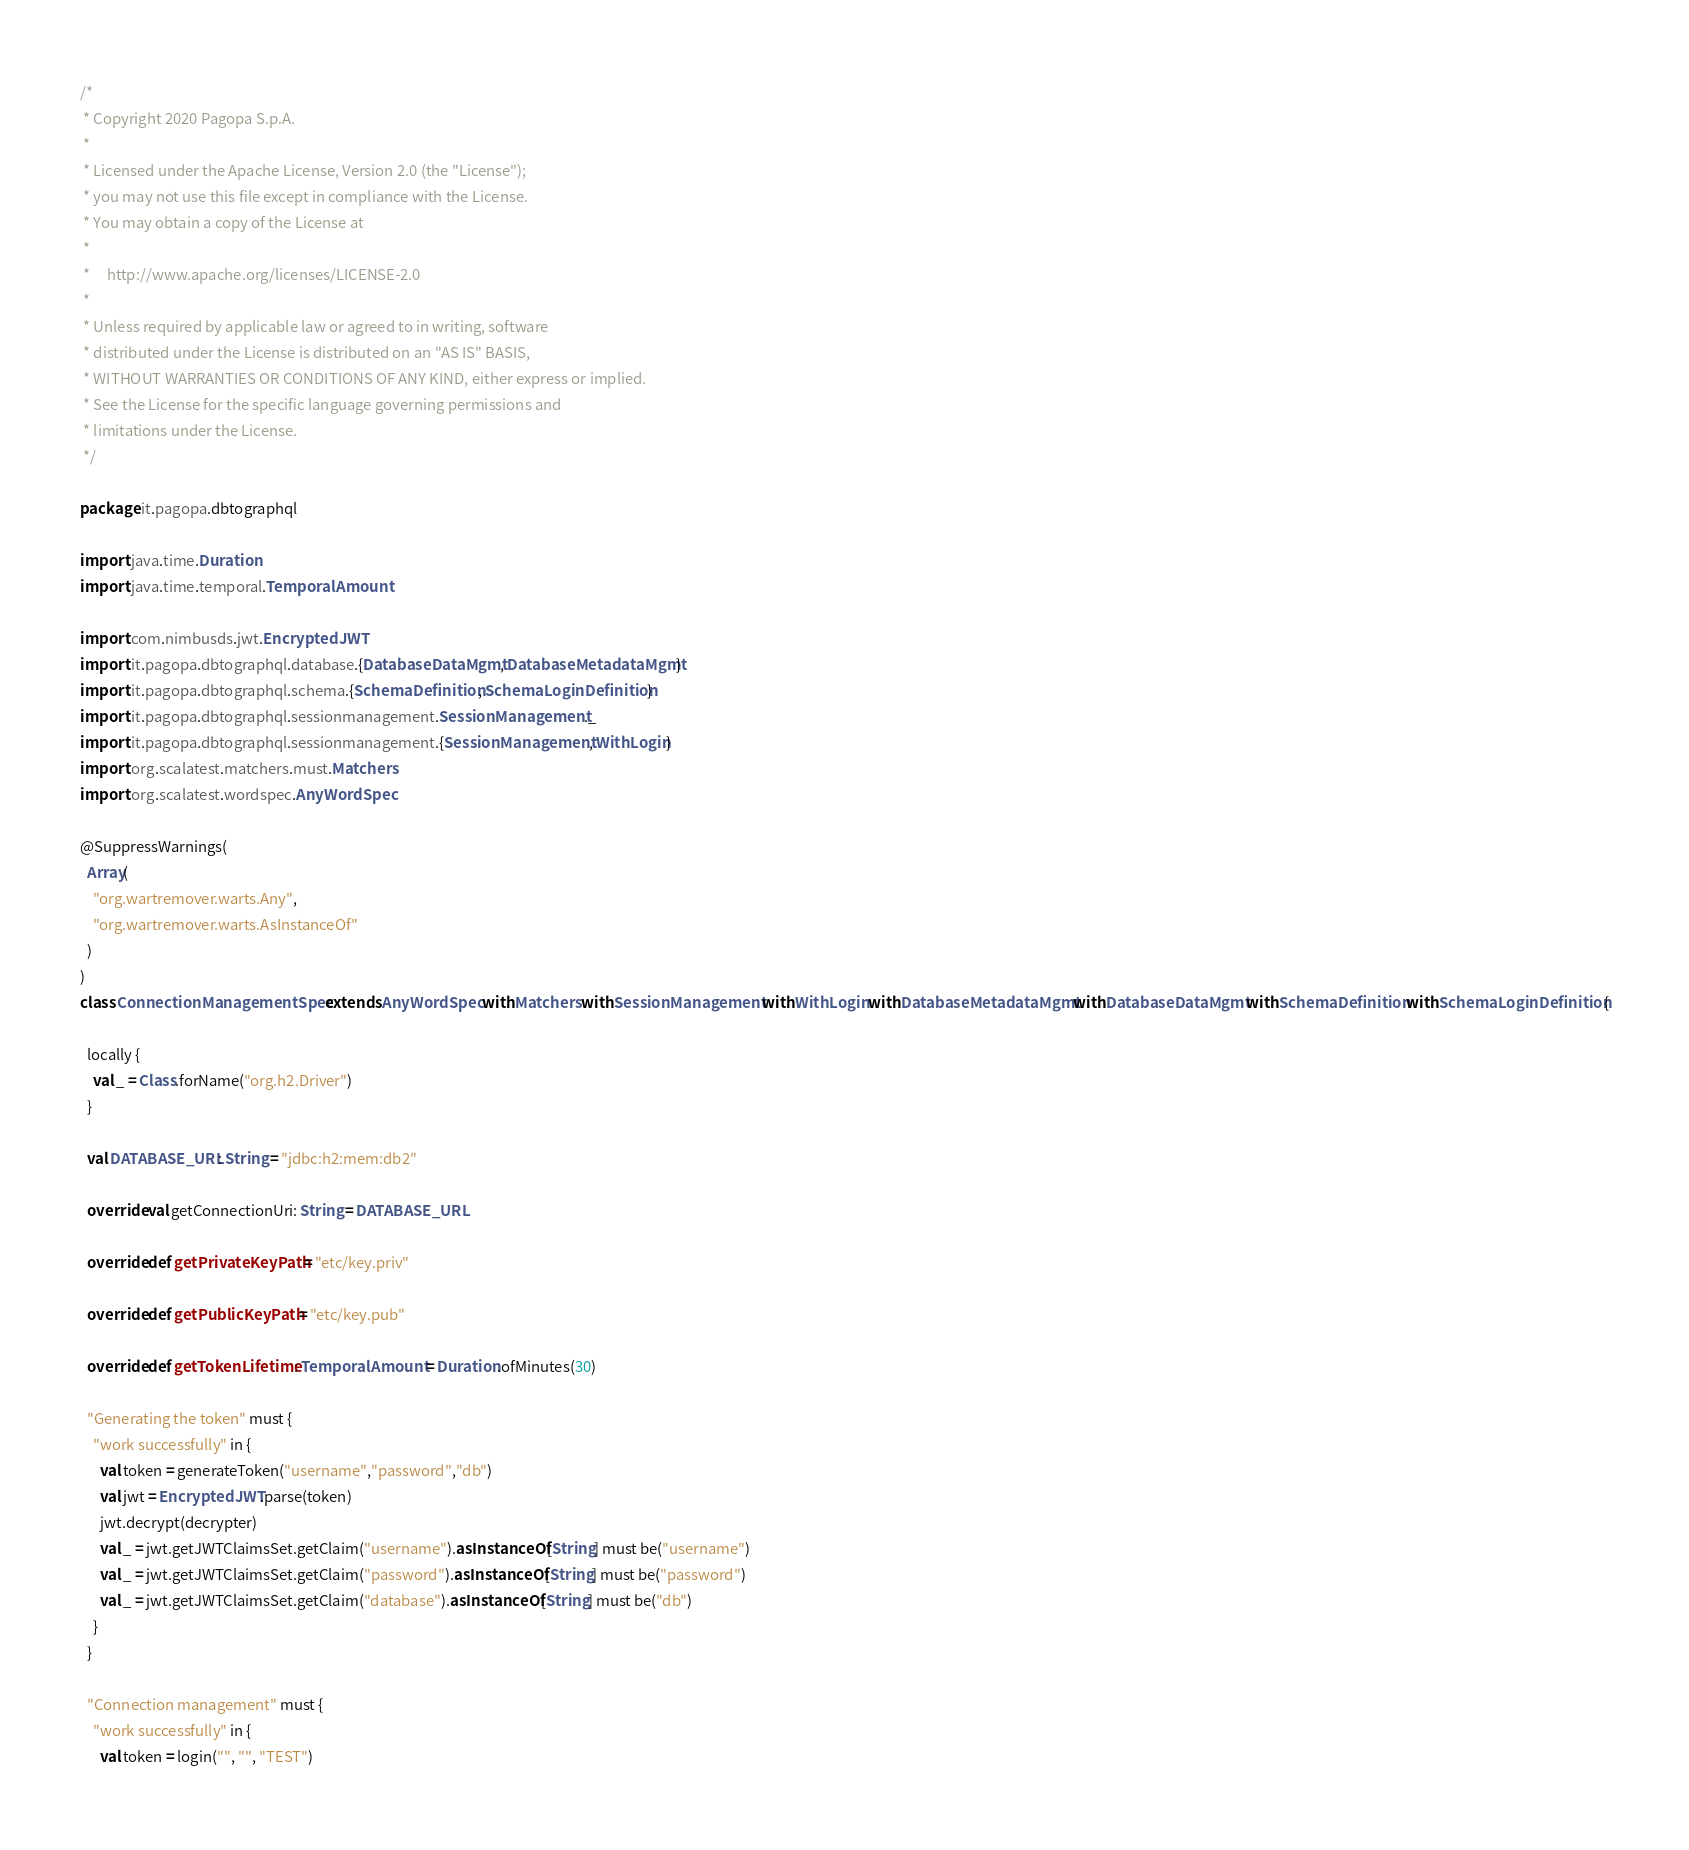Convert code to text. <code><loc_0><loc_0><loc_500><loc_500><_Scala_>/*
 * Copyright 2020 Pagopa S.p.A.
 *
 * Licensed under the Apache License, Version 2.0 (the "License");
 * you may not use this file except in compliance with the License.
 * You may obtain a copy of the License at
 *
 *     http://www.apache.org/licenses/LICENSE-2.0
 *
 * Unless required by applicable law or agreed to in writing, software
 * distributed under the License is distributed on an "AS IS" BASIS,
 * WITHOUT WARRANTIES OR CONDITIONS OF ANY KIND, either express or implied.
 * See the License for the specific language governing permissions and
 * limitations under the License.
 */

package it.pagopa.dbtographql

import java.time.Duration
import java.time.temporal.TemporalAmount

import com.nimbusds.jwt.EncryptedJWT
import it.pagopa.dbtographql.database.{DatabaseDataMgmt, DatabaseMetadataMgmt}
import it.pagopa.dbtographql.schema.{SchemaDefinition, SchemaLoginDefinition}
import it.pagopa.dbtographql.sessionmanagement.SessionManagement._
import it.pagopa.dbtographql.sessionmanagement.{SessionManagement, WithLogin}
import org.scalatest.matchers.must.Matchers
import org.scalatest.wordspec.AnyWordSpec

@SuppressWarnings(
  Array(
    "org.wartremover.warts.Any",
    "org.wartremover.warts.AsInstanceOf"
  )
)
class ConnectionManagementSpec extends AnyWordSpec with Matchers with SessionManagement with WithLogin with DatabaseMetadataMgmt with DatabaseDataMgmt with SchemaDefinition with SchemaLoginDefinition {

  locally {
    val _ = Class.forName("org.h2.Driver")
  }

  val DATABASE_URL: String = "jdbc:h2:mem:db2"

  override val getConnectionUri: String = DATABASE_URL

  override def getPrivateKeyPath = "etc/key.priv"

  override def getPublicKeyPath = "etc/key.pub"

  override def getTokenLifetime: TemporalAmount = Duration.ofMinutes(30)

  "Generating the token" must {
    "work successfully" in {
      val token = generateToken("username","password","db")
      val jwt = EncryptedJWT.parse(token)
      jwt.decrypt(decrypter)
      val _ = jwt.getJWTClaimsSet.getClaim("username").asInstanceOf[String] must be("username")
      val _ = jwt.getJWTClaimsSet.getClaim("password").asInstanceOf[String] must be("password")
      val _ = jwt.getJWTClaimsSet.getClaim("database").asInstanceOf[String] must be("db")
    }
  }

  "Connection management" must {
    "work successfully" in {
      val token = login("", "", "TEST")</code> 